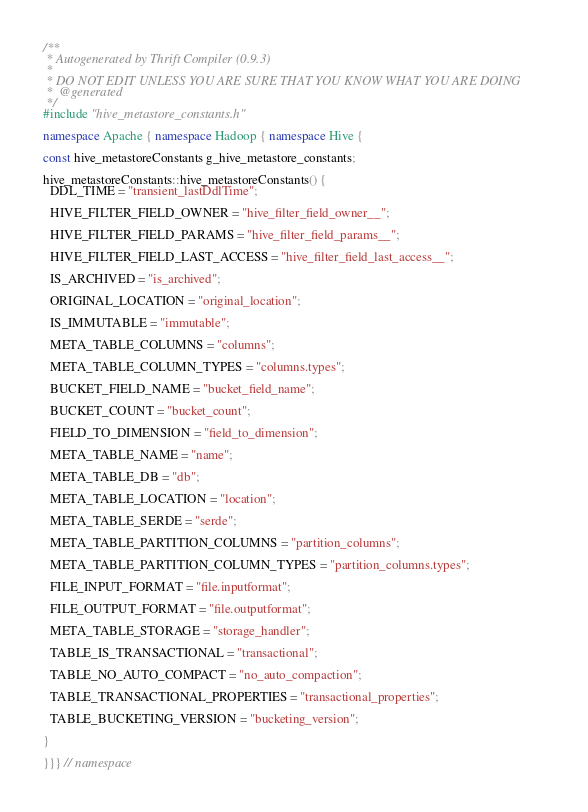<code> <loc_0><loc_0><loc_500><loc_500><_C++_>/**
 * Autogenerated by Thrift Compiler (0.9.3)
 *
 * DO NOT EDIT UNLESS YOU ARE SURE THAT YOU KNOW WHAT YOU ARE DOING
 *  @generated
 */
#include "hive_metastore_constants.h"

namespace Apache { namespace Hadoop { namespace Hive {

const hive_metastoreConstants g_hive_metastore_constants;

hive_metastoreConstants::hive_metastoreConstants() {
  DDL_TIME = "transient_lastDdlTime";

  HIVE_FILTER_FIELD_OWNER = "hive_filter_field_owner__";

  HIVE_FILTER_FIELD_PARAMS = "hive_filter_field_params__";

  HIVE_FILTER_FIELD_LAST_ACCESS = "hive_filter_field_last_access__";

  IS_ARCHIVED = "is_archived";

  ORIGINAL_LOCATION = "original_location";

  IS_IMMUTABLE = "immutable";

  META_TABLE_COLUMNS = "columns";

  META_TABLE_COLUMN_TYPES = "columns.types";

  BUCKET_FIELD_NAME = "bucket_field_name";

  BUCKET_COUNT = "bucket_count";

  FIELD_TO_DIMENSION = "field_to_dimension";

  META_TABLE_NAME = "name";

  META_TABLE_DB = "db";

  META_TABLE_LOCATION = "location";

  META_TABLE_SERDE = "serde";

  META_TABLE_PARTITION_COLUMNS = "partition_columns";

  META_TABLE_PARTITION_COLUMN_TYPES = "partition_columns.types";

  FILE_INPUT_FORMAT = "file.inputformat";

  FILE_OUTPUT_FORMAT = "file.outputformat";

  META_TABLE_STORAGE = "storage_handler";

  TABLE_IS_TRANSACTIONAL = "transactional";

  TABLE_NO_AUTO_COMPACT = "no_auto_compaction";

  TABLE_TRANSACTIONAL_PROPERTIES = "transactional_properties";

  TABLE_BUCKETING_VERSION = "bucketing_version";

}

}}} // namespace

</code> 